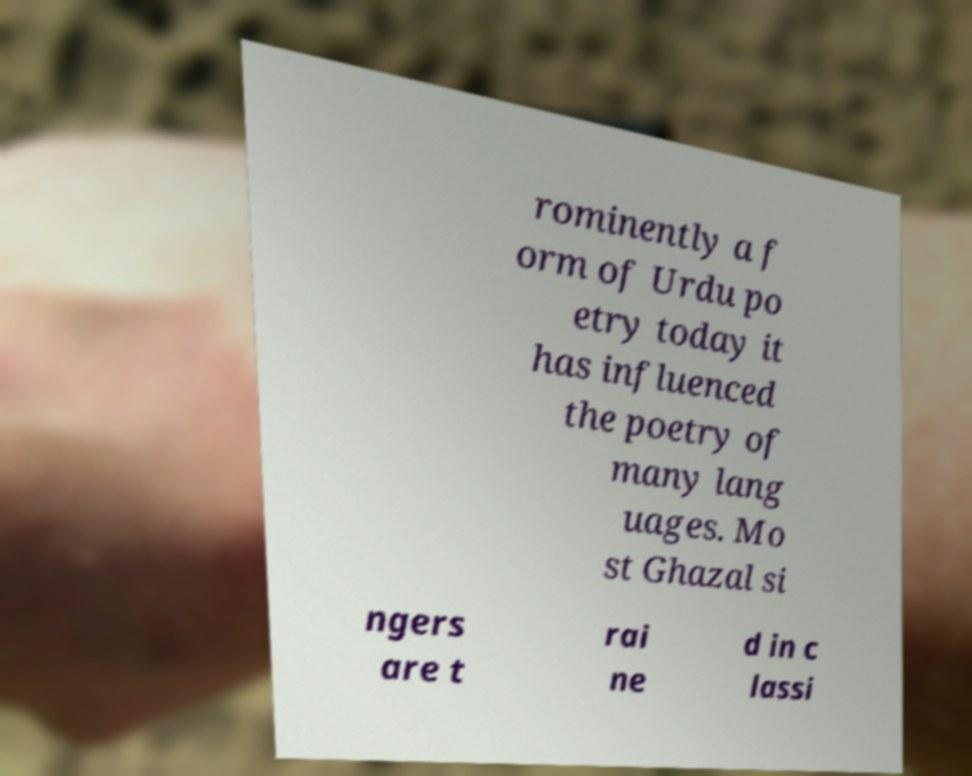Could you assist in decoding the text presented in this image and type it out clearly? rominently a f orm of Urdu po etry today it has influenced the poetry of many lang uages. Mo st Ghazal si ngers are t rai ne d in c lassi 